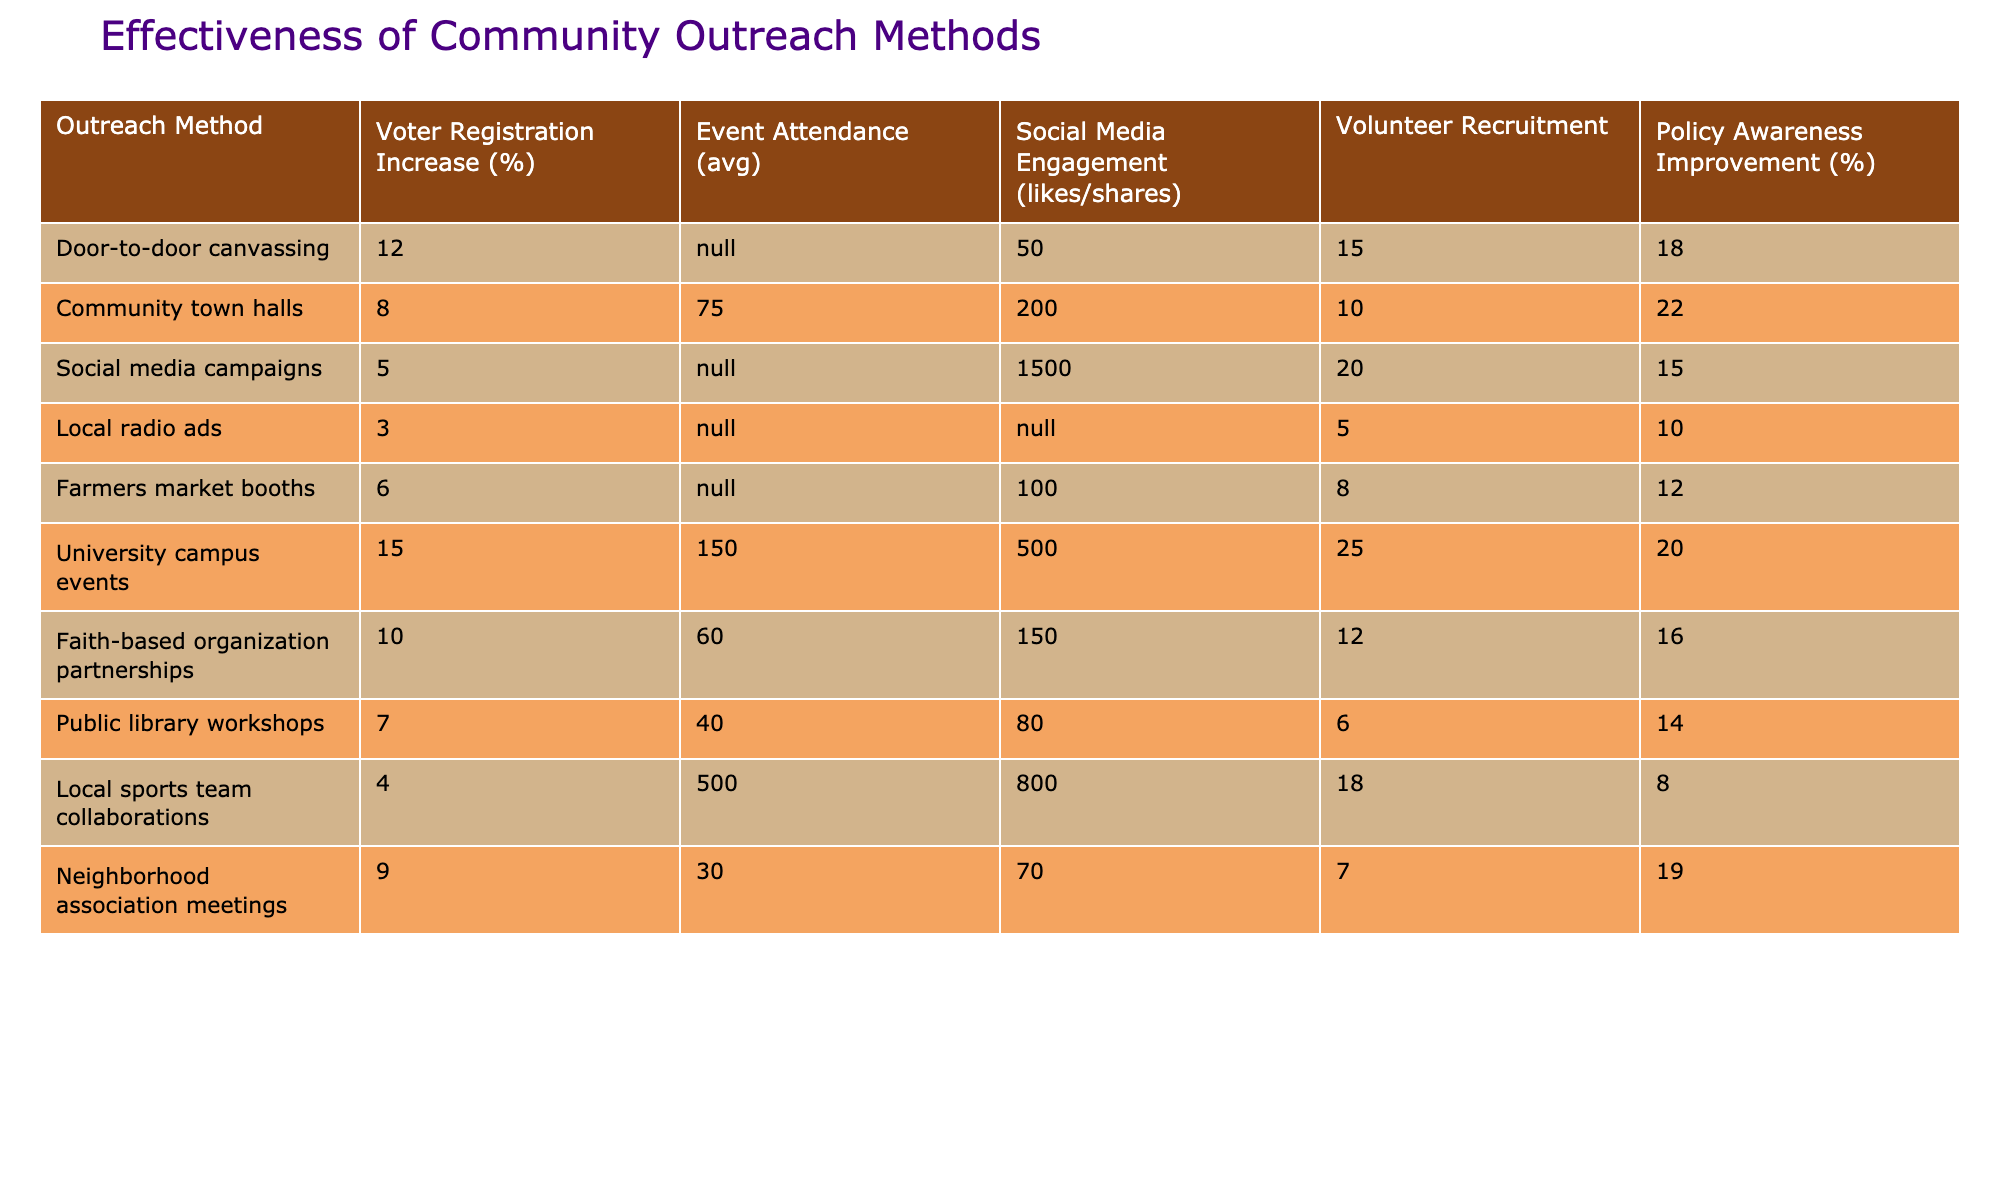What outreach method has the highest voter registration increase? According to the table, the outreach method with the highest voter registration increase is University campus events, which shows a 15% increase.
Answer: 15% What is the average event attendance for community town halls? The table specifies that community town halls have an average event attendance of 75.
Answer: 75 Which outreach method has the least social media engagement in likes/shares? Local radio ads show no social media engagement recorded, thus having the least engagement.
Answer: Yes What is the total voter registration increase for the top three outreach methods? The top three methods by voter registration increase are University campus events (15%), Door-to-door canvassing (12%), and Faith-based organization partnerships (10%). Summing these values gives 15 + 12 + 10 = 37.
Answer: 37% What outreach method had the highest average event attendance? Local sports team collaborations had the highest average event attendance at 500.
Answer: 500 How many outreach methods improved policy awareness by more than 15%? The outreach methods improving policy awareness over 15% are University campus events (20%), Community town halls (22%), and Door-to-door canvassing (18%). That's a total of 3 methods.
Answer: 3 What is the difference in voter registration increase between Door-to-door canvassing and Social media campaigns? Door-to-door canvassing has a 12% increase while Social media campaigns have a 5% increase. The difference is 12 - 5 = 7%.
Answer: 7% Which method had the highest volunteer recruitment number? University campus events recorded the highest volunteer recruitment number at 25.
Answer: 25 What percentage of outreach methods resulted in at least a 10% improvement in policy awareness? The outreach methods that resulted in a 10% or more improvement in policy awareness are University campus events (20%), Community town halls (22%), Door-to-door canvassing (18%), and Faith-based organization partnerships (16%). That's 4 out of 10 methods, or 40%.
Answer: 40% Is it true that Farmers market booths had a higher social media engagement than Local radio ads? Farmers market booths had 100 likes/shares, while Local radio ads show no engagement. Therefore, it is true that Farmers market booths had higher engagement.
Answer: Yes 